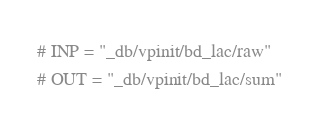Convert code to text. <code><loc_0><loc_0><loc_500><loc_500><_Crystal_># INP = "_db/vpinit/bd_lac/raw"
# OUT = "_db/vpinit/bd_lac/sum"
</code> 